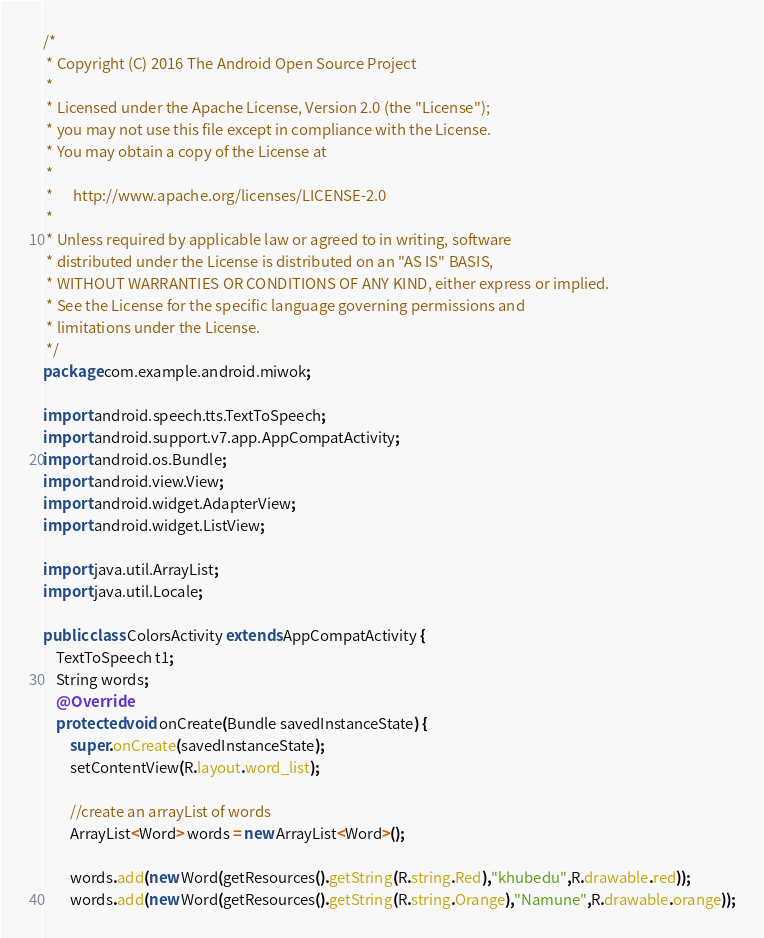Convert code to text. <code><loc_0><loc_0><loc_500><loc_500><_Java_>/*
 * Copyright (C) 2016 The Android Open Source Project
 *
 * Licensed under the Apache License, Version 2.0 (the "License");
 * you may not use this file except in compliance with the License.
 * You may obtain a copy of the License at
 *
 *      http://www.apache.org/licenses/LICENSE-2.0
 *
 * Unless required by applicable law or agreed to in writing, software
 * distributed under the License is distributed on an "AS IS" BASIS,
 * WITHOUT WARRANTIES OR CONDITIONS OF ANY KIND, either express or implied.
 * See the License for the specific language governing permissions and
 * limitations under the License.
 */
package com.example.android.miwok;

import android.speech.tts.TextToSpeech;
import android.support.v7.app.AppCompatActivity;
import android.os.Bundle;
import android.view.View;
import android.widget.AdapterView;
import android.widget.ListView;

import java.util.ArrayList;
import java.util.Locale;

public class ColorsActivity extends AppCompatActivity {
    TextToSpeech t1;
    String words;
    @Override
    protected void onCreate(Bundle savedInstanceState) {
        super.onCreate(savedInstanceState);
        setContentView(R.layout.word_list);

        //create an arrayList of words
        ArrayList<Word> words = new ArrayList<Word>();

        words.add(new Word(getResources().getString(R.string.Red),"khubedu",R.drawable.red));
        words.add(new Word(getResources().getString(R.string.Orange),"Namune",R.drawable.orange));</code> 